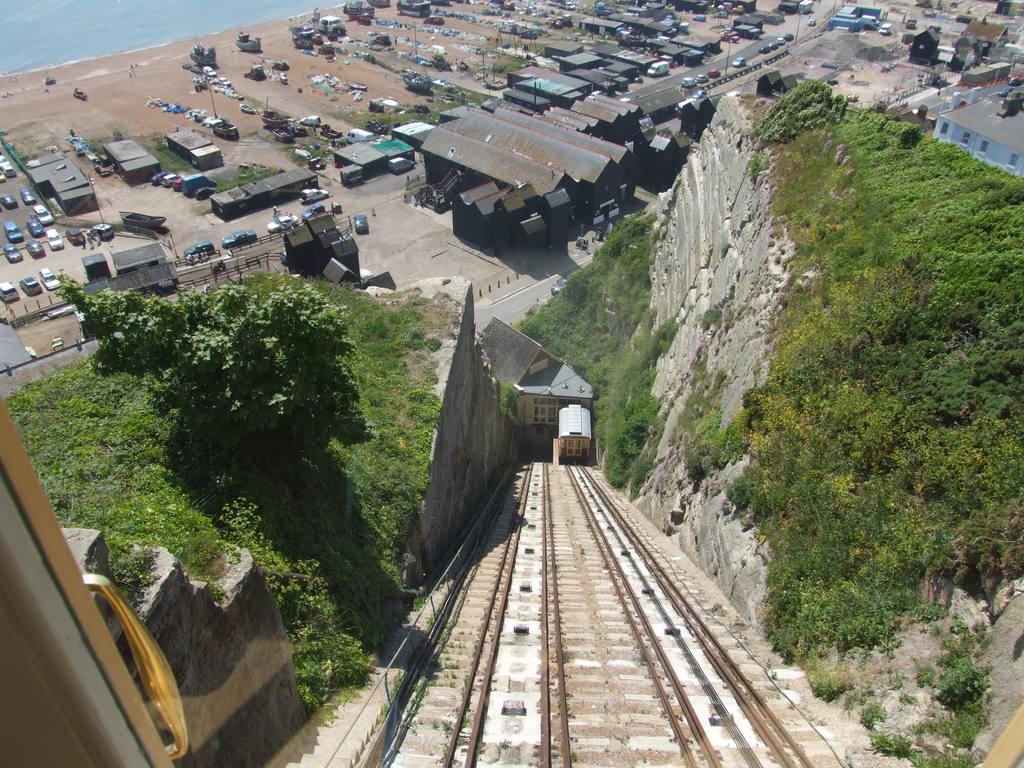Please provide a concise description of this image. In this picture we can see plants on the right side and left side, on the left side there is a tree, in the background we can see houses, cars, some vehicles and grass, it looks like water at the left top of the picture. 